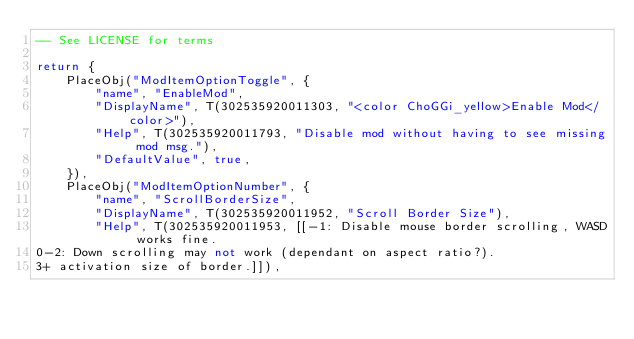Convert code to text. <code><loc_0><loc_0><loc_500><loc_500><_Lua_>-- See LICENSE for terms

return {
	PlaceObj("ModItemOptionToggle", {
		"name", "EnableMod",
		"DisplayName", T(302535920011303, "<color ChoGGi_yellow>Enable Mod</color>"),
		"Help", T(302535920011793, "Disable mod without having to see missing mod msg."),
		"DefaultValue", true,
	}),
	PlaceObj("ModItemOptionNumber", {
		"name", "ScrollBorderSize",
		"DisplayName", T(302535920011952, "Scroll Border Size"),
		"Help", T(302535920011953, [[-1: Disable mouse border scrolling, WASD works fine.
0-2: Down scrolling may not work (dependant on aspect ratio?).
3+ activation size of border.]]),</code> 